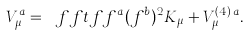Convert formula to latex. <formula><loc_0><loc_0><loc_500><loc_500>V _ { \mu } ^ { a } = \ f f t { f f ^ { a } } { ( f ^ { b } ) ^ { 2 } } K _ { \mu } + V _ { \mu } ^ { ( 4 ) \, a } .</formula> 